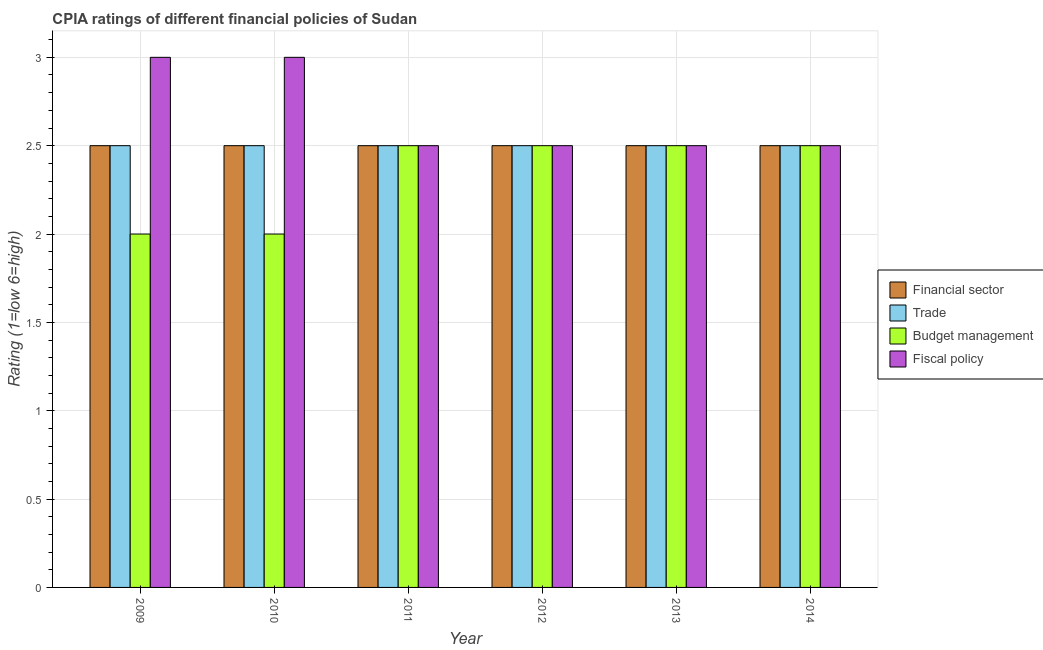How many different coloured bars are there?
Ensure brevity in your answer.  4. How many groups of bars are there?
Ensure brevity in your answer.  6. What is the label of the 3rd group of bars from the left?
Provide a short and direct response. 2011. In how many cases, is the number of bars for a given year not equal to the number of legend labels?
Offer a very short reply. 0. Across all years, what is the maximum cpia rating of budget management?
Your answer should be compact. 2.5. In which year was the cpia rating of fiscal policy maximum?
Your answer should be compact. 2009. In the year 2009, what is the difference between the cpia rating of trade and cpia rating of financial sector?
Give a very brief answer. 0. In how many years, is the cpia rating of financial sector greater than 2?
Make the answer very short. 6. What is the ratio of the cpia rating of budget management in 2011 to that in 2014?
Your answer should be very brief. 1. What is the difference between the highest and the second highest cpia rating of financial sector?
Make the answer very short. 0. Is the sum of the cpia rating of financial sector in 2009 and 2013 greater than the maximum cpia rating of trade across all years?
Your response must be concise. Yes. What does the 1st bar from the left in 2009 represents?
Your answer should be compact. Financial sector. What does the 2nd bar from the right in 2011 represents?
Your answer should be very brief. Budget management. Is it the case that in every year, the sum of the cpia rating of financial sector and cpia rating of trade is greater than the cpia rating of budget management?
Your answer should be very brief. Yes. How many bars are there?
Your answer should be very brief. 24. What is the difference between two consecutive major ticks on the Y-axis?
Give a very brief answer. 0.5. Are the values on the major ticks of Y-axis written in scientific E-notation?
Provide a succinct answer. No. How many legend labels are there?
Make the answer very short. 4. What is the title of the graph?
Provide a succinct answer. CPIA ratings of different financial policies of Sudan. Does "Mammal species" appear as one of the legend labels in the graph?
Offer a terse response. No. What is the label or title of the X-axis?
Offer a very short reply. Year. What is the Rating (1=low 6=high) of Budget management in 2009?
Provide a succinct answer. 2. What is the Rating (1=low 6=high) of Financial sector in 2010?
Ensure brevity in your answer.  2.5. What is the Rating (1=low 6=high) of Fiscal policy in 2010?
Your answer should be very brief. 3. What is the Rating (1=low 6=high) in Budget management in 2012?
Provide a succinct answer. 2.5. What is the Rating (1=low 6=high) of Financial sector in 2013?
Your answer should be compact. 2.5. What is the Rating (1=low 6=high) in Trade in 2013?
Provide a succinct answer. 2.5. What is the Rating (1=low 6=high) in Budget management in 2013?
Offer a very short reply. 2.5. What is the Rating (1=low 6=high) in Trade in 2014?
Your answer should be very brief. 2.5. Across all years, what is the maximum Rating (1=low 6=high) of Trade?
Give a very brief answer. 2.5. Across all years, what is the minimum Rating (1=low 6=high) in Budget management?
Offer a very short reply. 2. What is the total Rating (1=low 6=high) in Trade in the graph?
Keep it short and to the point. 15. What is the total Rating (1=low 6=high) in Fiscal policy in the graph?
Give a very brief answer. 16. What is the difference between the Rating (1=low 6=high) in Trade in 2009 and that in 2010?
Your answer should be compact. 0. What is the difference between the Rating (1=low 6=high) of Fiscal policy in 2009 and that in 2010?
Offer a very short reply. 0. What is the difference between the Rating (1=low 6=high) of Financial sector in 2009 and that in 2011?
Your answer should be very brief. 0. What is the difference between the Rating (1=low 6=high) of Financial sector in 2009 and that in 2012?
Ensure brevity in your answer.  0. What is the difference between the Rating (1=low 6=high) in Trade in 2009 and that in 2012?
Provide a short and direct response. 0. What is the difference between the Rating (1=low 6=high) in Budget management in 2009 and that in 2012?
Offer a very short reply. -0.5. What is the difference between the Rating (1=low 6=high) of Financial sector in 2009 and that in 2014?
Make the answer very short. 0. What is the difference between the Rating (1=low 6=high) in Trade in 2009 and that in 2014?
Make the answer very short. 0. What is the difference between the Rating (1=low 6=high) of Fiscal policy in 2009 and that in 2014?
Provide a succinct answer. 0.5. What is the difference between the Rating (1=low 6=high) of Financial sector in 2010 and that in 2012?
Give a very brief answer. 0. What is the difference between the Rating (1=low 6=high) of Trade in 2010 and that in 2013?
Your answer should be compact. 0. What is the difference between the Rating (1=low 6=high) of Budget management in 2010 and that in 2013?
Offer a very short reply. -0.5. What is the difference between the Rating (1=low 6=high) in Financial sector in 2010 and that in 2014?
Your response must be concise. 0. What is the difference between the Rating (1=low 6=high) in Budget management in 2010 and that in 2014?
Give a very brief answer. -0.5. What is the difference between the Rating (1=low 6=high) of Fiscal policy in 2010 and that in 2014?
Offer a terse response. 0.5. What is the difference between the Rating (1=low 6=high) of Financial sector in 2011 and that in 2012?
Give a very brief answer. 0. What is the difference between the Rating (1=low 6=high) of Financial sector in 2011 and that in 2013?
Your answer should be very brief. 0. What is the difference between the Rating (1=low 6=high) of Trade in 2011 and that in 2013?
Ensure brevity in your answer.  0. What is the difference between the Rating (1=low 6=high) of Budget management in 2011 and that in 2013?
Your answer should be compact. 0. What is the difference between the Rating (1=low 6=high) of Financial sector in 2011 and that in 2014?
Provide a short and direct response. 0. What is the difference between the Rating (1=low 6=high) in Budget management in 2011 and that in 2014?
Your answer should be very brief. 0. What is the difference between the Rating (1=low 6=high) of Trade in 2012 and that in 2013?
Your answer should be compact. 0. What is the difference between the Rating (1=low 6=high) of Fiscal policy in 2012 and that in 2013?
Offer a terse response. 0. What is the difference between the Rating (1=low 6=high) in Budget management in 2012 and that in 2014?
Ensure brevity in your answer.  0. What is the difference between the Rating (1=low 6=high) in Financial sector in 2013 and that in 2014?
Offer a very short reply. 0. What is the difference between the Rating (1=low 6=high) of Budget management in 2013 and that in 2014?
Give a very brief answer. 0. What is the difference between the Rating (1=low 6=high) in Financial sector in 2009 and the Rating (1=low 6=high) in Trade in 2010?
Keep it short and to the point. 0. What is the difference between the Rating (1=low 6=high) of Financial sector in 2009 and the Rating (1=low 6=high) of Fiscal policy in 2010?
Offer a terse response. -0.5. What is the difference between the Rating (1=low 6=high) in Trade in 2009 and the Rating (1=low 6=high) in Budget management in 2010?
Ensure brevity in your answer.  0.5. What is the difference between the Rating (1=low 6=high) in Trade in 2009 and the Rating (1=low 6=high) in Fiscal policy in 2010?
Offer a very short reply. -0.5. What is the difference between the Rating (1=low 6=high) in Budget management in 2009 and the Rating (1=low 6=high) in Fiscal policy in 2010?
Ensure brevity in your answer.  -1. What is the difference between the Rating (1=low 6=high) of Financial sector in 2009 and the Rating (1=low 6=high) of Trade in 2011?
Your answer should be compact. 0. What is the difference between the Rating (1=low 6=high) in Financial sector in 2009 and the Rating (1=low 6=high) in Budget management in 2011?
Provide a short and direct response. 0. What is the difference between the Rating (1=low 6=high) in Trade in 2009 and the Rating (1=low 6=high) in Budget management in 2011?
Ensure brevity in your answer.  0. What is the difference between the Rating (1=low 6=high) of Financial sector in 2009 and the Rating (1=low 6=high) of Trade in 2012?
Offer a terse response. 0. What is the difference between the Rating (1=low 6=high) of Financial sector in 2009 and the Rating (1=low 6=high) of Fiscal policy in 2012?
Provide a short and direct response. 0. What is the difference between the Rating (1=low 6=high) in Trade in 2009 and the Rating (1=low 6=high) in Budget management in 2012?
Make the answer very short. 0. What is the difference between the Rating (1=low 6=high) of Trade in 2009 and the Rating (1=low 6=high) of Fiscal policy in 2012?
Offer a very short reply. 0. What is the difference between the Rating (1=low 6=high) of Financial sector in 2009 and the Rating (1=low 6=high) of Trade in 2013?
Your response must be concise. 0. What is the difference between the Rating (1=low 6=high) in Financial sector in 2009 and the Rating (1=low 6=high) in Budget management in 2013?
Provide a succinct answer. 0. What is the difference between the Rating (1=low 6=high) of Financial sector in 2009 and the Rating (1=low 6=high) of Fiscal policy in 2013?
Offer a terse response. 0. What is the difference between the Rating (1=low 6=high) in Trade in 2009 and the Rating (1=low 6=high) in Budget management in 2013?
Keep it short and to the point. 0. What is the difference between the Rating (1=low 6=high) in Trade in 2009 and the Rating (1=low 6=high) in Budget management in 2014?
Offer a very short reply. 0. What is the difference between the Rating (1=low 6=high) in Budget management in 2009 and the Rating (1=low 6=high) in Fiscal policy in 2014?
Your answer should be compact. -0.5. What is the difference between the Rating (1=low 6=high) in Financial sector in 2010 and the Rating (1=low 6=high) in Trade in 2011?
Offer a terse response. 0. What is the difference between the Rating (1=low 6=high) of Financial sector in 2010 and the Rating (1=low 6=high) of Budget management in 2011?
Your answer should be very brief. 0. What is the difference between the Rating (1=low 6=high) in Financial sector in 2010 and the Rating (1=low 6=high) in Fiscal policy in 2011?
Offer a very short reply. 0. What is the difference between the Rating (1=low 6=high) in Trade in 2010 and the Rating (1=low 6=high) in Fiscal policy in 2011?
Give a very brief answer. 0. What is the difference between the Rating (1=low 6=high) in Budget management in 2010 and the Rating (1=low 6=high) in Fiscal policy in 2011?
Give a very brief answer. -0.5. What is the difference between the Rating (1=low 6=high) in Financial sector in 2010 and the Rating (1=low 6=high) in Trade in 2012?
Your response must be concise. 0. What is the difference between the Rating (1=low 6=high) in Trade in 2010 and the Rating (1=low 6=high) in Fiscal policy in 2012?
Your answer should be very brief. 0. What is the difference between the Rating (1=low 6=high) of Financial sector in 2010 and the Rating (1=low 6=high) of Trade in 2013?
Make the answer very short. 0. What is the difference between the Rating (1=low 6=high) in Trade in 2010 and the Rating (1=low 6=high) in Budget management in 2013?
Provide a short and direct response. 0. What is the difference between the Rating (1=low 6=high) in Trade in 2010 and the Rating (1=low 6=high) in Fiscal policy in 2013?
Keep it short and to the point. 0. What is the difference between the Rating (1=low 6=high) in Budget management in 2010 and the Rating (1=low 6=high) in Fiscal policy in 2013?
Ensure brevity in your answer.  -0.5. What is the difference between the Rating (1=low 6=high) of Financial sector in 2010 and the Rating (1=low 6=high) of Trade in 2014?
Offer a very short reply. 0. What is the difference between the Rating (1=low 6=high) in Financial sector in 2010 and the Rating (1=low 6=high) in Budget management in 2014?
Provide a succinct answer. 0. What is the difference between the Rating (1=low 6=high) of Trade in 2010 and the Rating (1=low 6=high) of Budget management in 2014?
Provide a succinct answer. 0. What is the difference between the Rating (1=low 6=high) of Trade in 2010 and the Rating (1=low 6=high) of Fiscal policy in 2014?
Give a very brief answer. 0. What is the difference between the Rating (1=low 6=high) in Financial sector in 2011 and the Rating (1=low 6=high) in Fiscal policy in 2012?
Your answer should be very brief. 0. What is the difference between the Rating (1=low 6=high) in Trade in 2011 and the Rating (1=low 6=high) in Budget management in 2012?
Give a very brief answer. 0. What is the difference between the Rating (1=low 6=high) of Trade in 2011 and the Rating (1=low 6=high) of Fiscal policy in 2012?
Give a very brief answer. 0. What is the difference between the Rating (1=low 6=high) in Budget management in 2011 and the Rating (1=low 6=high) in Fiscal policy in 2012?
Provide a short and direct response. 0. What is the difference between the Rating (1=low 6=high) of Financial sector in 2011 and the Rating (1=low 6=high) of Trade in 2013?
Ensure brevity in your answer.  0. What is the difference between the Rating (1=low 6=high) in Financial sector in 2011 and the Rating (1=low 6=high) in Budget management in 2013?
Keep it short and to the point. 0. What is the difference between the Rating (1=low 6=high) in Trade in 2011 and the Rating (1=low 6=high) in Fiscal policy in 2013?
Offer a terse response. 0. What is the difference between the Rating (1=low 6=high) in Financial sector in 2011 and the Rating (1=low 6=high) in Trade in 2014?
Provide a short and direct response. 0. What is the difference between the Rating (1=low 6=high) of Trade in 2011 and the Rating (1=low 6=high) of Budget management in 2014?
Offer a terse response. 0. What is the difference between the Rating (1=low 6=high) of Budget management in 2011 and the Rating (1=low 6=high) of Fiscal policy in 2014?
Offer a terse response. 0. What is the difference between the Rating (1=low 6=high) in Financial sector in 2012 and the Rating (1=low 6=high) in Trade in 2013?
Offer a very short reply. 0. What is the difference between the Rating (1=low 6=high) in Trade in 2012 and the Rating (1=low 6=high) in Budget management in 2013?
Offer a terse response. 0. What is the difference between the Rating (1=low 6=high) of Trade in 2012 and the Rating (1=low 6=high) of Fiscal policy in 2013?
Provide a succinct answer. 0. What is the difference between the Rating (1=low 6=high) of Budget management in 2012 and the Rating (1=low 6=high) of Fiscal policy in 2013?
Provide a short and direct response. 0. What is the difference between the Rating (1=low 6=high) in Financial sector in 2012 and the Rating (1=low 6=high) in Budget management in 2014?
Your answer should be compact. 0. What is the difference between the Rating (1=low 6=high) of Financial sector in 2012 and the Rating (1=low 6=high) of Fiscal policy in 2014?
Keep it short and to the point. 0. What is the difference between the Rating (1=low 6=high) of Trade in 2012 and the Rating (1=low 6=high) of Fiscal policy in 2014?
Offer a terse response. 0. What is the difference between the Rating (1=low 6=high) of Financial sector in 2013 and the Rating (1=low 6=high) of Trade in 2014?
Offer a terse response. 0. What is the difference between the Rating (1=low 6=high) of Financial sector in 2013 and the Rating (1=low 6=high) of Budget management in 2014?
Keep it short and to the point. 0. What is the difference between the Rating (1=low 6=high) in Trade in 2013 and the Rating (1=low 6=high) in Fiscal policy in 2014?
Make the answer very short. 0. What is the difference between the Rating (1=low 6=high) of Budget management in 2013 and the Rating (1=low 6=high) of Fiscal policy in 2014?
Make the answer very short. 0. What is the average Rating (1=low 6=high) in Financial sector per year?
Your answer should be compact. 2.5. What is the average Rating (1=low 6=high) of Trade per year?
Make the answer very short. 2.5. What is the average Rating (1=low 6=high) in Budget management per year?
Your answer should be very brief. 2.33. What is the average Rating (1=low 6=high) in Fiscal policy per year?
Your answer should be compact. 2.67. In the year 2009, what is the difference between the Rating (1=low 6=high) of Financial sector and Rating (1=low 6=high) of Trade?
Ensure brevity in your answer.  0. In the year 2009, what is the difference between the Rating (1=low 6=high) of Trade and Rating (1=low 6=high) of Fiscal policy?
Offer a very short reply. -0.5. In the year 2009, what is the difference between the Rating (1=low 6=high) of Budget management and Rating (1=low 6=high) of Fiscal policy?
Offer a very short reply. -1. In the year 2010, what is the difference between the Rating (1=low 6=high) in Financial sector and Rating (1=low 6=high) in Trade?
Your response must be concise. 0. In the year 2010, what is the difference between the Rating (1=low 6=high) in Financial sector and Rating (1=low 6=high) in Budget management?
Keep it short and to the point. 0.5. In the year 2010, what is the difference between the Rating (1=low 6=high) of Trade and Rating (1=low 6=high) of Fiscal policy?
Provide a succinct answer. -0.5. In the year 2011, what is the difference between the Rating (1=low 6=high) of Financial sector and Rating (1=low 6=high) of Trade?
Offer a very short reply. 0. In the year 2011, what is the difference between the Rating (1=low 6=high) of Financial sector and Rating (1=low 6=high) of Budget management?
Offer a terse response. 0. In the year 2011, what is the difference between the Rating (1=low 6=high) in Financial sector and Rating (1=low 6=high) in Fiscal policy?
Provide a succinct answer. 0. In the year 2011, what is the difference between the Rating (1=low 6=high) of Budget management and Rating (1=low 6=high) of Fiscal policy?
Your answer should be compact. 0. In the year 2012, what is the difference between the Rating (1=low 6=high) in Financial sector and Rating (1=low 6=high) in Budget management?
Provide a short and direct response. 0. In the year 2012, what is the difference between the Rating (1=low 6=high) in Trade and Rating (1=low 6=high) in Fiscal policy?
Provide a succinct answer. 0. In the year 2012, what is the difference between the Rating (1=low 6=high) of Budget management and Rating (1=low 6=high) of Fiscal policy?
Your answer should be very brief. 0. In the year 2013, what is the difference between the Rating (1=low 6=high) of Financial sector and Rating (1=low 6=high) of Trade?
Offer a terse response. 0. In the year 2013, what is the difference between the Rating (1=low 6=high) of Financial sector and Rating (1=low 6=high) of Fiscal policy?
Your response must be concise. 0. In the year 2013, what is the difference between the Rating (1=low 6=high) of Budget management and Rating (1=low 6=high) of Fiscal policy?
Give a very brief answer. 0. In the year 2014, what is the difference between the Rating (1=low 6=high) of Financial sector and Rating (1=low 6=high) of Budget management?
Give a very brief answer. 0. In the year 2014, what is the difference between the Rating (1=low 6=high) of Financial sector and Rating (1=low 6=high) of Fiscal policy?
Your answer should be compact. 0. In the year 2014, what is the difference between the Rating (1=low 6=high) in Trade and Rating (1=low 6=high) in Budget management?
Your answer should be compact. 0. In the year 2014, what is the difference between the Rating (1=low 6=high) in Trade and Rating (1=low 6=high) in Fiscal policy?
Make the answer very short. 0. In the year 2014, what is the difference between the Rating (1=low 6=high) of Budget management and Rating (1=low 6=high) of Fiscal policy?
Offer a terse response. 0. What is the ratio of the Rating (1=low 6=high) of Financial sector in 2009 to that in 2010?
Your response must be concise. 1. What is the ratio of the Rating (1=low 6=high) of Trade in 2009 to that in 2010?
Provide a succinct answer. 1. What is the ratio of the Rating (1=low 6=high) in Financial sector in 2009 to that in 2011?
Give a very brief answer. 1. What is the ratio of the Rating (1=low 6=high) in Trade in 2009 to that in 2011?
Your answer should be compact. 1. What is the ratio of the Rating (1=low 6=high) in Fiscal policy in 2009 to that in 2011?
Make the answer very short. 1.2. What is the ratio of the Rating (1=low 6=high) of Financial sector in 2009 to that in 2012?
Provide a succinct answer. 1. What is the ratio of the Rating (1=low 6=high) of Trade in 2009 to that in 2012?
Provide a short and direct response. 1. What is the ratio of the Rating (1=low 6=high) in Fiscal policy in 2009 to that in 2012?
Your answer should be compact. 1.2. What is the ratio of the Rating (1=low 6=high) in Trade in 2009 to that in 2013?
Offer a very short reply. 1. What is the ratio of the Rating (1=low 6=high) in Financial sector in 2009 to that in 2014?
Provide a succinct answer. 1. What is the ratio of the Rating (1=low 6=high) in Financial sector in 2010 to that in 2011?
Keep it short and to the point. 1. What is the ratio of the Rating (1=low 6=high) in Trade in 2010 to that in 2011?
Keep it short and to the point. 1. What is the ratio of the Rating (1=low 6=high) in Trade in 2010 to that in 2012?
Provide a succinct answer. 1. What is the ratio of the Rating (1=low 6=high) of Financial sector in 2010 to that in 2013?
Provide a short and direct response. 1. What is the ratio of the Rating (1=low 6=high) of Trade in 2010 to that in 2013?
Keep it short and to the point. 1. What is the ratio of the Rating (1=low 6=high) of Fiscal policy in 2010 to that in 2013?
Your answer should be very brief. 1.2. What is the ratio of the Rating (1=low 6=high) of Financial sector in 2010 to that in 2014?
Keep it short and to the point. 1. What is the ratio of the Rating (1=low 6=high) in Trade in 2010 to that in 2014?
Give a very brief answer. 1. What is the ratio of the Rating (1=low 6=high) of Budget management in 2010 to that in 2014?
Make the answer very short. 0.8. What is the ratio of the Rating (1=low 6=high) in Fiscal policy in 2010 to that in 2014?
Provide a succinct answer. 1.2. What is the ratio of the Rating (1=low 6=high) in Financial sector in 2011 to that in 2012?
Your answer should be very brief. 1. What is the ratio of the Rating (1=low 6=high) of Fiscal policy in 2011 to that in 2012?
Ensure brevity in your answer.  1. What is the ratio of the Rating (1=low 6=high) of Financial sector in 2011 to that in 2013?
Offer a very short reply. 1. What is the ratio of the Rating (1=low 6=high) in Trade in 2011 to that in 2013?
Provide a succinct answer. 1. What is the ratio of the Rating (1=low 6=high) in Budget management in 2011 to that in 2013?
Make the answer very short. 1. What is the ratio of the Rating (1=low 6=high) of Financial sector in 2011 to that in 2014?
Offer a very short reply. 1. What is the ratio of the Rating (1=low 6=high) in Trade in 2011 to that in 2014?
Ensure brevity in your answer.  1. What is the ratio of the Rating (1=low 6=high) of Fiscal policy in 2011 to that in 2014?
Offer a terse response. 1. What is the ratio of the Rating (1=low 6=high) of Financial sector in 2012 to that in 2013?
Your answer should be compact. 1. What is the ratio of the Rating (1=low 6=high) of Fiscal policy in 2012 to that in 2013?
Keep it short and to the point. 1. What is the ratio of the Rating (1=low 6=high) in Trade in 2012 to that in 2014?
Your answer should be compact. 1. What is the ratio of the Rating (1=low 6=high) in Fiscal policy in 2013 to that in 2014?
Offer a very short reply. 1. What is the difference between the highest and the second highest Rating (1=low 6=high) of Financial sector?
Offer a very short reply. 0. What is the difference between the highest and the second highest Rating (1=low 6=high) of Trade?
Provide a short and direct response. 0. What is the difference between the highest and the second highest Rating (1=low 6=high) in Fiscal policy?
Provide a succinct answer. 0. What is the difference between the highest and the lowest Rating (1=low 6=high) in Financial sector?
Ensure brevity in your answer.  0. What is the difference between the highest and the lowest Rating (1=low 6=high) of Trade?
Your answer should be compact. 0. 